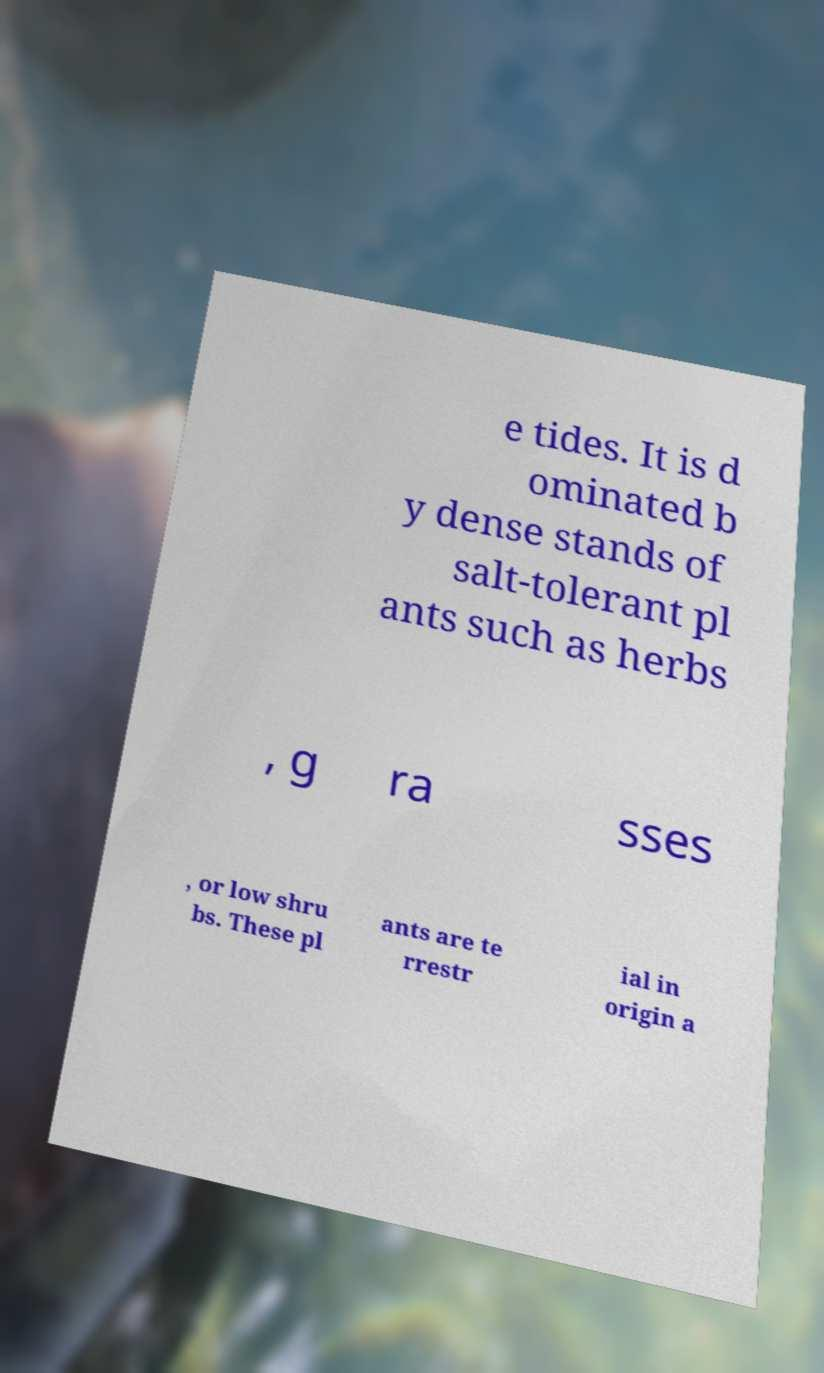What messages or text are displayed in this image? I need them in a readable, typed format. e tides. It is d ominated b y dense stands of salt-tolerant pl ants such as herbs , g ra sses , or low shru bs. These pl ants are te rrestr ial in origin a 